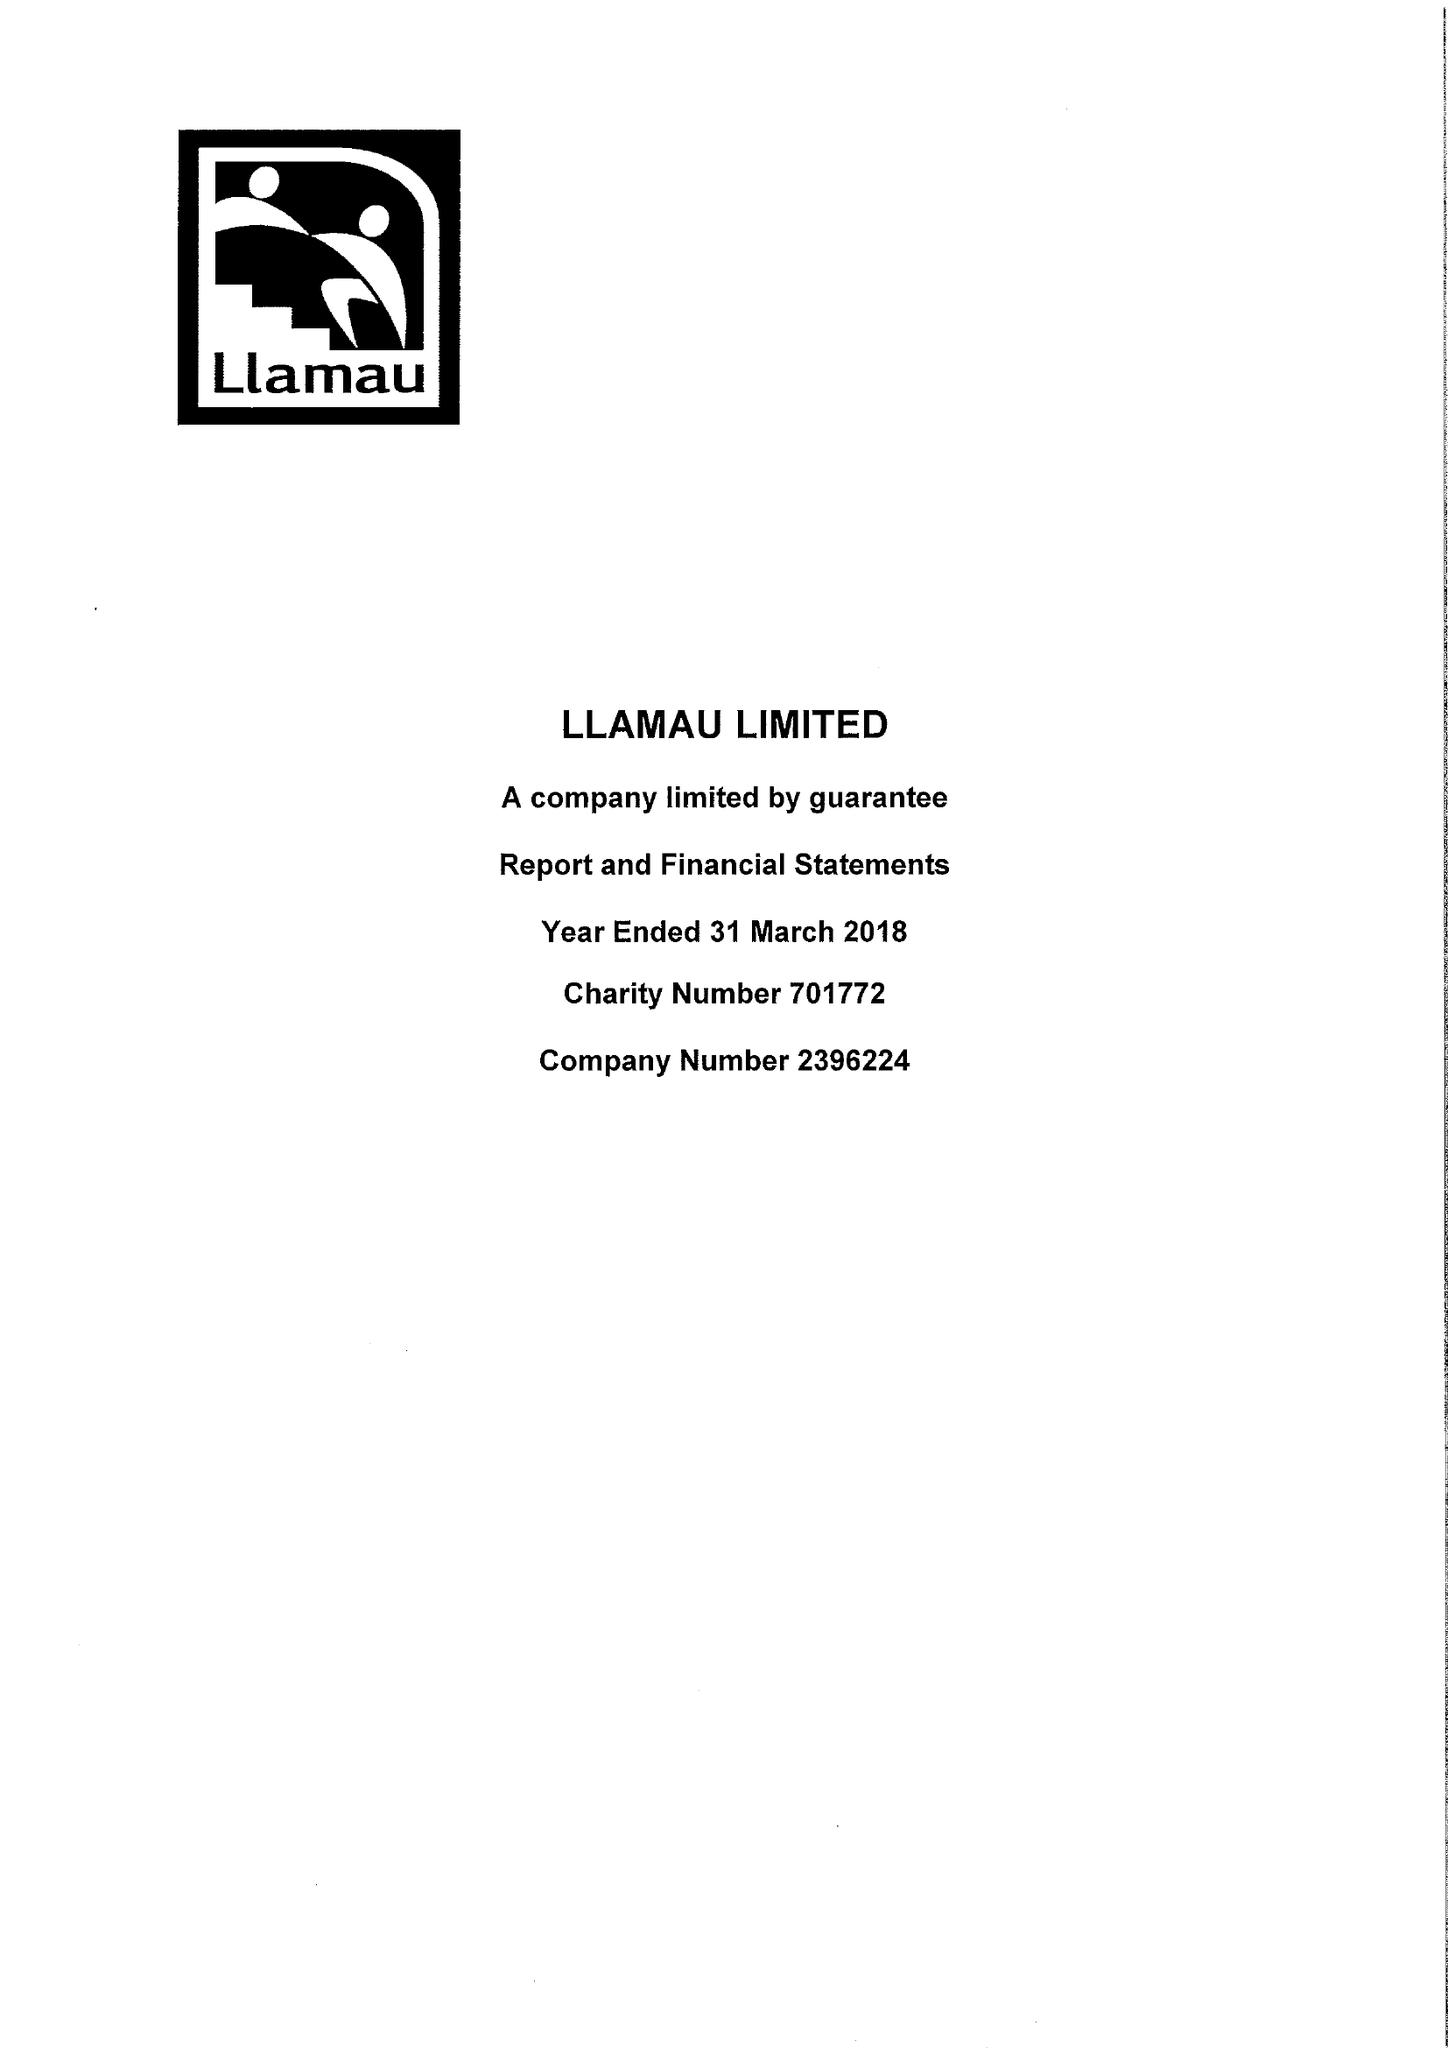What is the value for the address__street_line?
Answer the question using a single word or phrase. 23-25 CATHEDRAL ROAD 